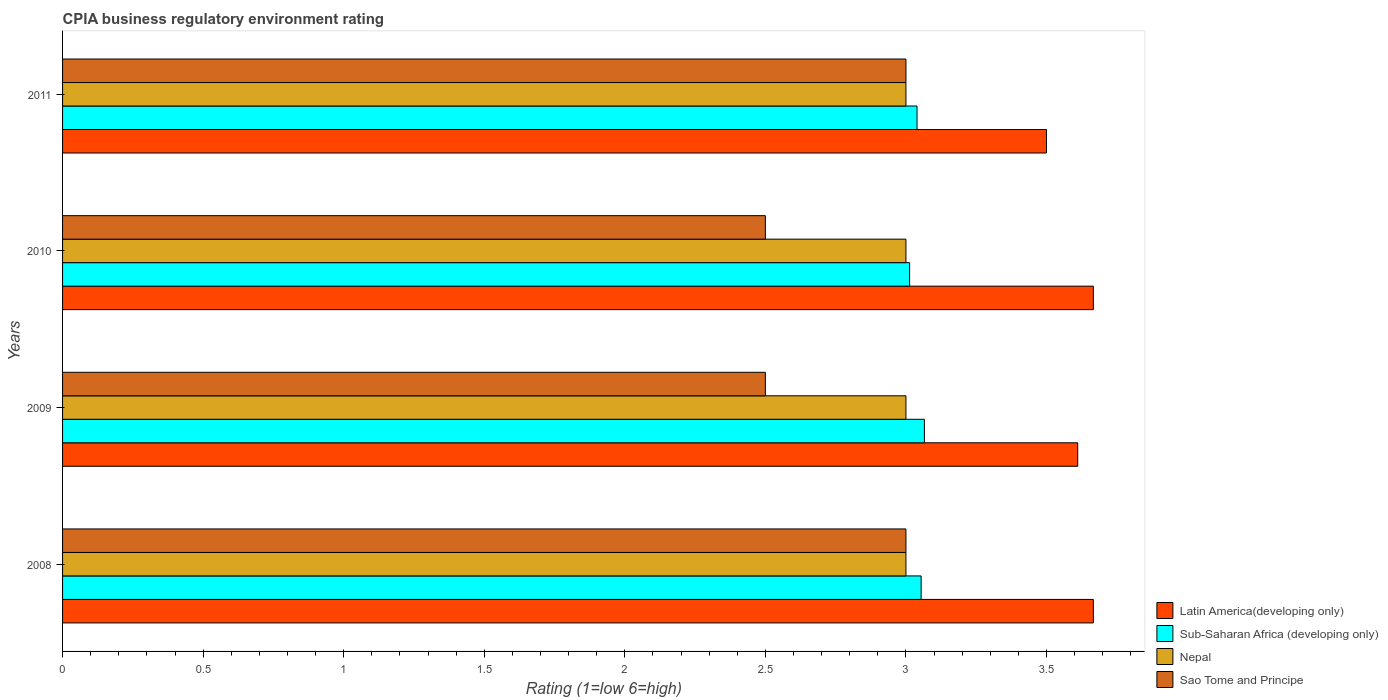How many different coloured bars are there?
Offer a very short reply. 4. Are the number of bars on each tick of the Y-axis equal?
Your answer should be compact. Yes. In how many cases, is the number of bars for a given year not equal to the number of legend labels?
Ensure brevity in your answer.  0. What is the CPIA rating in Sub-Saharan Africa (developing only) in 2010?
Provide a succinct answer. 3.01. Across all years, what is the maximum CPIA rating in Latin America(developing only)?
Offer a very short reply. 3.67. In which year was the CPIA rating in Sub-Saharan Africa (developing only) minimum?
Your answer should be very brief. 2010. What is the total CPIA rating in Nepal in the graph?
Offer a terse response. 12. What is the difference between the CPIA rating in Sub-Saharan Africa (developing only) in 2008 and that in 2011?
Provide a succinct answer. 0.01. What is the average CPIA rating in Sub-Saharan Africa (developing only) per year?
Ensure brevity in your answer.  3.04. In the year 2010, what is the difference between the CPIA rating in Sub-Saharan Africa (developing only) and CPIA rating in Sao Tome and Principe?
Offer a terse response. 0.51. Is the CPIA rating in Latin America(developing only) in 2008 less than that in 2011?
Ensure brevity in your answer.  No. What is the difference between the highest and the second highest CPIA rating in Nepal?
Your response must be concise. 0. What is the difference between the highest and the lowest CPIA rating in Latin America(developing only)?
Offer a very short reply. 0.17. In how many years, is the CPIA rating in Latin America(developing only) greater than the average CPIA rating in Latin America(developing only) taken over all years?
Make the answer very short. 2. What does the 3rd bar from the top in 2009 represents?
Provide a succinct answer. Sub-Saharan Africa (developing only). What does the 3rd bar from the bottom in 2008 represents?
Offer a terse response. Nepal. How many years are there in the graph?
Give a very brief answer. 4. Does the graph contain grids?
Your answer should be compact. No. How many legend labels are there?
Make the answer very short. 4. What is the title of the graph?
Make the answer very short. CPIA business regulatory environment rating. What is the label or title of the X-axis?
Your response must be concise. Rating (1=low 6=high). What is the label or title of the Y-axis?
Provide a succinct answer. Years. What is the Rating (1=low 6=high) in Latin America(developing only) in 2008?
Offer a very short reply. 3.67. What is the Rating (1=low 6=high) of Sub-Saharan Africa (developing only) in 2008?
Keep it short and to the point. 3.05. What is the Rating (1=low 6=high) of Nepal in 2008?
Provide a short and direct response. 3. What is the Rating (1=low 6=high) in Latin America(developing only) in 2009?
Offer a terse response. 3.61. What is the Rating (1=low 6=high) of Sub-Saharan Africa (developing only) in 2009?
Ensure brevity in your answer.  3.07. What is the Rating (1=low 6=high) of Sao Tome and Principe in 2009?
Provide a succinct answer. 2.5. What is the Rating (1=low 6=high) of Latin America(developing only) in 2010?
Ensure brevity in your answer.  3.67. What is the Rating (1=low 6=high) in Sub-Saharan Africa (developing only) in 2010?
Provide a succinct answer. 3.01. What is the Rating (1=low 6=high) of Sao Tome and Principe in 2010?
Your answer should be compact. 2.5. What is the Rating (1=low 6=high) of Latin America(developing only) in 2011?
Offer a terse response. 3.5. What is the Rating (1=low 6=high) in Sub-Saharan Africa (developing only) in 2011?
Provide a succinct answer. 3.04. What is the Rating (1=low 6=high) in Nepal in 2011?
Offer a very short reply. 3. Across all years, what is the maximum Rating (1=low 6=high) of Latin America(developing only)?
Keep it short and to the point. 3.67. Across all years, what is the maximum Rating (1=low 6=high) in Sub-Saharan Africa (developing only)?
Provide a succinct answer. 3.07. Across all years, what is the minimum Rating (1=low 6=high) of Latin America(developing only)?
Make the answer very short. 3.5. Across all years, what is the minimum Rating (1=low 6=high) in Sub-Saharan Africa (developing only)?
Offer a terse response. 3.01. Across all years, what is the minimum Rating (1=low 6=high) of Nepal?
Offer a terse response. 3. What is the total Rating (1=low 6=high) of Latin America(developing only) in the graph?
Give a very brief answer. 14.44. What is the total Rating (1=low 6=high) in Sub-Saharan Africa (developing only) in the graph?
Offer a very short reply. 12.17. What is the total Rating (1=low 6=high) of Nepal in the graph?
Give a very brief answer. 12. What is the total Rating (1=low 6=high) in Sao Tome and Principe in the graph?
Keep it short and to the point. 11. What is the difference between the Rating (1=low 6=high) in Latin America(developing only) in 2008 and that in 2009?
Offer a terse response. 0.06. What is the difference between the Rating (1=low 6=high) of Sub-Saharan Africa (developing only) in 2008 and that in 2009?
Provide a short and direct response. -0.01. What is the difference between the Rating (1=low 6=high) of Sao Tome and Principe in 2008 and that in 2009?
Make the answer very short. 0.5. What is the difference between the Rating (1=low 6=high) of Sub-Saharan Africa (developing only) in 2008 and that in 2010?
Provide a short and direct response. 0.04. What is the difference between the Rating (1=low 6=high) in Nepal in 2008 and that in 2010?
Your response must be concise. 0. What is the difference between the Rating (1=low 6=high) in Sao Tome and Principe in 2008 and that in 2010?
Your answer should be compact. 0.5. What is the difference between the Rating (1=low 6=high) in Latin America(developing only) in 2008 and that in 2011?
Offer a terse response. 0.17. What is the difference between the Rating (1=low 6=high) in Sub-Saharan Africa (developing only) in 2008 and that in 2011?
Provide a succinct answer. 0.01. What is the difference between the Rating (1=low 6=high) in Nepal in 2008 and that in 2011?
Give a very brief answer. 0. What is the difference between the Rating (1=low 6=high) of Latin America(developing only) in 2009 and that in 2010?
Offer a very short reply. -0.06. What is the difference between the Rating (1=low 6=high) in Sub-Saharan Africa (developing only) in 2009 and that in 2010?
Offer a terse response. 0.05. What is the difference between the Rating (1=low 6=high) in Nepal in 2009 and that in 2010?
Make the answer very short. 0. What is the difference between the Rating (1=low 6=high) of Latin America(developing only) in 2009 and that in 2011?
Make the answer very short. 0.11. What is the difference between the Rating (1=low 6=high) of Sub-Saharan Africa (developing only) in 2009 and that in 2011?
Your answer should be very brief. 0.03. What is the difference between the Rating (1=low 6=high) in Nepal in 2009 and that in 2011?
Your response must be concise. 0. What is the difference between the Rating (1=low 6=high) of Latin America(developing only) in 2010 and that in 2011?
Offer a very short reply. 0.17. What is the difference between the Rating (1=low 6=high) in Sub-Saharan Africa (developing only) in 2010 and that in 2011?
Give a very brief answer. -0.03. What is the difference between the Rating (1=low 6=high) of Nepal in 2010 and that in 2011?
Ensure brevity in your answer.  0. What is the difference between the Rating (1=low 6=high) of Latin America(developing only) in 2008 and the Rating (1=low 6=high) of Sub-Saharan Africa (developing only) in 2009?
Your answer should be compact. 0.6. What is the difference between the Rating (1=low 6=high) of Sub-Saharan Africa (developing only) in 2008 and the Rating (1=low 6=high) of Nepal in 2009?
Offer a terse response. 0.05. What is the difference between the Rating (1=low 6=high) in Sub-Saharan Africa (developing only) in 2008 and the Rating (1=low 6=high) in Sao Tome and Principe in 2009?
Your answer should be very brief. 0.55. What is the difference between the Rating (1=low 6=high) in Latin America(developing only) in 2008 and the Rating (1=low 6=high) in Sub-Saharan Africa (developing only) in 2010?
Offer a terse response. 0.65. What is the difference between the Rating (1=low 6=high) in Latin America(developing only) in 2008 and the Rating (1=low 6=high) in Nepal in 2010?
Provide a short and direct response. 0.67. What is the difference between the Rating (1=low 6=high) of Latin America(developing only) in 2008 and the Rating (1=low 6=high) of Sao Tome and Principe in 2010?
Your response must be concise. 1.17. What is the difference between the Rating (1=low 6=high) in Sub-Saharan Africa (developing only) in 2008 and the Rating (1=low 6=high) in Nepal in 2010?
Your answer should be very brief. 0.05. What is the difference between the Rating (1=low 6=high) of Sub-Saharan Africa (developing only) in 2008 and the Rating (1=low 6=high) of Sao Tome and Principe in 2010?
Provide a short and direct response. 0.55. What is the difference between the Rating (1=low 6=high) in Latin America(developing only) in 2008 and the Rating (1=low 6=high) in Sub-Saharan Africa (developing only) in 2011?
Provide a succinct answer. 0.63. What is the difference between the Rating (1=low 6=high) of Latin America(developing only) in 2008 and the Rating (1=low 6=high) of Sao Tome and Principe in 2011?
Make the answer very short. 0.67. What is the difference between the Rating (1=low 6=high) in Sub-Saharan Africa (developing only) in 2008 and the Rating (1=low 6=high) in Nepal in 2011?
Provide a short and direct response. 0.05. What is the difference between the Rating (1=low 6=high) in Sub-Saharan Africa (developing only) in 2008 and the Rating (1=low 6=high) in Sao Tome and Principe in 2011?
Keep it short and to the point. 0.05. What is the difference between the Rating (1=low 6=high) in Nepal in 2008 and the Rating (1=low 6=high) in Sao Tome and Principe in 2011?
Provide a short and direct response. 0. What is the difference between the Rating (1=low 6=high) of Latin America(developing only) in 2009 and the Rating (1=low 6=high) of Sub-Saharan Africa (developing only) in 2010?
Provide a short and direct response. 0.6. What is the difference between the Rating (1=low 6=high) of Latin America(developing only) in 2009 and the Rating (1=low 6=high) of Nepal in 2010?
Make the answer very short. 0.61. What is the difference between the Rating (1=low 6=high) in Latin America(developing only) in 2009 and the Rating (1=low 6=high) in Sao Tome and Principe in 2010?
Your answer should be compact. 1.11. What is the difference between the Rating (1=low 6=high) in Sub-Saharan Africa (developing only) in 2009 and the Rating (1=low 6=high) in Nepal in 2010?
Make the answer very short. 0.07. What is the difference between the Rating (1=low 6=high) in Sub-Saharan Africa (developing only) in 2009 and the Rating (1=low 6=high) in Sao Tome and Principe in 2010?
Keep it short and to the point. 0.57. What is the difference between the Rating (1=low 6=high) of Nepal in 2009 and the Rating (1=low 6=high) of Sao Tome and Principe in 2010?
Your response must be concise. 0.5. What is the difference between the Rating (1=low 6=high) of Latin America(developing only) in 2009 and the Rating (1=low 6=high) of Sub-Saharan Africa (developing only) in 2011?
Keep it short and to the point. 0.57. What is the difference between the Rating (1=low 6=high) in Latin America(developing only) in 2009 and the Rating (1=low 6=high) in Nepal in 2011?
Offer a very short reply. 0.61. What is the difference between the Rating (1=low 6=high) of Latin America(developing only) in 2009 and the Rating (1=low 6=high) of Sao Tome and Principe in 2011?
Make the answer very short. 0.61. What is the difference between the Rating (1=low 6=high) in Sub-Saharan Africa (developing only) in 2009 and the Rating (1=low 6=high) in Nepal in 2011?
Provide a succinct answer. 0.07. What is the difference between the Rating (1=low 6=high) in Sub-Saharan Africa (developing only) in 2009 and the Rating (1=low 6=high) in Sao Tome and Principe in 2011?
Your response must be concise. 0.07. What is the difference between the Rating (1=low 6=high) in Latin America(developing only) in 2010 and the Rating (1=low 6=high) in Sub-Saharan Africa (developing only) in 2011?
Make the answer very short. 0.63. What is the difference between the Rating (1=low 6=high) in Latin America(developing only) in 2010 and the Rating (1=low 6=high) in Nepal in 2011?
Ensure brevity in your answer.  0.67. What is the difference between the Rating (1=low 6=high) of Latin America(developing only) in 2010 and the Rating (1=low 6=high) of Sao Tome and Principe in 2011?
Your response must be concise. 0.67. What is the difference between the Rating (1=low 6=high) of Sub-Saharan Africa (developing only) in 2010 and the Rating (1=low 6=high) of Nepal in 2011?
Keep it short and to the point. 0.01. What is the difference between the Rating (1=low 6=high) in Sub-Saharan Africa (developing only) in 2010 and the Rating (1=low 6=high) in Sao Tome and Principe in 2011?
Your response must be concise. 0.01. What is the difference between the Rating (1=low 6=high) of Nepal in 2010 and the Rating (1=low 6=high) of Sao Tome and Principe in 2011?
Give a very brief answer. 0. What is the average Rating (1=low 6=high) of Latin America(developing only) per year?
Your response must be concise. 3.61. What is the average Rating (1=low 6=high) of Sub-Saharan Africa (developing only) per year?
Keep it short and to the point. 3.04. What is the average Rating (1=low 6=high) of Nepal per year?
Keep it short and to the point. 3. What is the average Rating (1=low 6=high) in Sao Tome and Principe per year?
Offer a terse response. 2.75. In the year 2008, what is the difference between the Rating (1=low 6=high) in Latin America(developing only) and Rating (1=low 6=high) in Sub-Saharan Africa (developing only)?
Make the answer very short. 0.61. In the year 2008, what is the difference between the Rating (1=low 6=high) of Sub-Saharan Africa (developing only) and Rating (1=low 6=high) of Nepal?
Give a very brief answer. 0.05. In the year 2008, what is the difference between the Rating (1=low 6=high) in Sub-Saharan Africa (developing only) and Rating (1=low 6=high) in Sao Tome and Principe?
Provide a succinct answer. 0.05. In the year 2009, what is the difference between the Rating (1=low 6=high) in Latin America(developing only) and Rating (1=low 6=high) in Sub-Saharan Africa (developing only)?
Your response must be concise. 0.55. In the year 2009, what is the difference between the Rating (1=low 6=high) of Latin America(developing only) and Rating (1=low 6=high) of Nepal?
Your answer should be very brief. 0.61. In the year 2009, what is the difference between the Rating (1=low 6=high) of Sub-Saharan Africa (developing only) and Rating (1=low 6=high) of Nepal?
Offer a terse response. 0.07. In the year 2009, what is the difference between the Rating (1=low 6=high) of Sub-Saharan Africa (developing only) and Rating (1=low 6=high) of Sao Tome and Principe?
Make the answer very short. 0.57. In the year 2010, what is the difference between the Rating (1=low 6=high) of Latin America(developing only) and Rating (1=low 6=high) of Sub-Saharan Africa (developing only)?
Your answer should be compact. 0.65. In the year 2010, what is the difference between the Rating (1=low 6=high) of Latin America(developing only) and Rating (1=low 6=high) of Sao Tome and Principe?
Your answer should be compact. 1.17. In the year 2010, what is the difference between the Rating (1=low 6=high) in Sub-Saharan Africa (developing only) and Rating (1=low 6=high) in Nepal?
Keep it short and to the point. 0.01. In the year 2010, what is the difference between the Rating (1=low 6=high) in Sub-Saharan Africa (developing only) and Rating (1=low 6=high) in Sao Tome and Principe?
Keep it short and to the point. 0.51. In the year 2011, what is the difference between the Rating (1=low 6=high) of Latin America(developing only) and Rating (1=low 6=high) of Sub-Saharan Africa (developing only)?
Your answer should be very brief. 0.46. In the year 2011, what is the difference between the Rating (1=low 6=high) in Latin America(developing only) and Rating (1=low 6=high) in Sao Tome and Principe?
Your response must be concise. 0.5. In the year 2011, what is the difference between the Rating (1=low 6=high) in Sub-Saharan Africa (developing only) and Rating (1=low 6=high) in Nepal?
Offer a terse response. 0.04. In the year 2011, what is the difference between the Rating (1=low 6=high) in Sub-Saharan Africa (developing only) and Rating (1=low 6=high) in Sao Tome and Principe?
Make the answer very short. 0.04. What is the ratio of the Rating (1=low 6=high) in Latin America(developing only) in 2008 to that in 2009?
Provide a short and direct response. 1.02. What is the ratio of the Rating (1=low 6=high) of Sub-Saharan Africa (developing only) in 2008 to that in 2009?
Ensure brevity in your answer.  1. What is the ratio of the Rating (1=low 6=high) of Nepal in 2008 to that in 2009?
Give a very brief answer. 1. What is the ratio of the Rating (1=low 6=high) in Latin America(developing only) in 2008 to that in 2010?
Offer a terse response. 1. What is the ratio of the Rating (1=low 6=high) in Sub-Saharan Africa (developing only) in 2008 to that in 2010?
Your answer should be compact. 1.01. What is the ratio of the Rating (1=low 6=high) in Sao Tome and Principe in 2008 to that in 2010?
Offer a very short reply. 1.2. What is the ratio of the Rating (1=low 6=high) in Latin America(developing only) in 2008 to that in 2011?
Ensure brevity in your answer.  1.05. What is the ratio of the Rating (1=low 6=high) in Sao Tome and Principe in 2008 to that in 2011?
Your answer should be very brief. 1. What is the ratio of the Rating (1=low 6=high) of Latin America(developing only) in 2009 to that in 2010?
Provide a short and direct response. 0.98. What is the ratio of the Rating (1=low 6=high) of Sub-Saharan Africa (developing only) in 2009 to that in 2010?
Your answer should be very brief. 1.02. What is the ratio of the Rating (1=low 6=high) in Sao Tome and Principe in 2009 to that in 2010?
Give a very brief answer. 1. What is the ratio of the Rating (1=low 6=high) of Latin America(developing only) in 2009 to that in 2011?
Ensure brevity in your answer.  1.03. What is the ratio of the Rating (1=low 6=high) of Sub-Saharan Africa (developing only) in 2009 to that in 2011?
Offer a very short reply. 1.01. What is the ratio of the Rating (1=low 6=high) in Sao Tome and Principe in 2009 to that in 2011?
Your response must be concise. 0.83. What is the ratio of the Rating (1=low 6=high) of Latin America(developing only) in 2010 to that in 2011?
Keep it short and to the point. 1.05. What is the difference between the highest and the second highest Rating (1=low 6=high) of Sub-Saharan Africa (developing only)?
Ensure brevity in your answer.  0.01. What is the difference between the highest and the lowest Rating (1=low 6=high) in Latin America(developing only)?
Make the answer very short. 0.17. What is the difference between the highest and the lowest Rating (1=low 6=high) in Sub-Saharan Africa (developing only)?
Give a very brief answer. 0.05. 